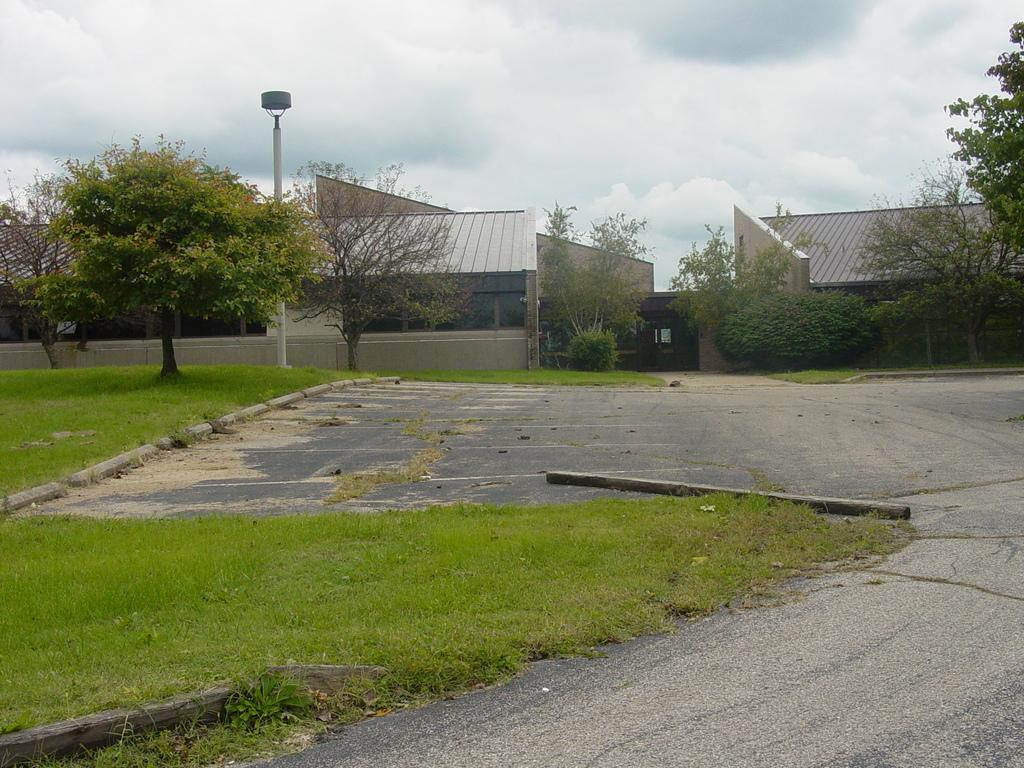Where is the image taken? The image is taken on a road. What can be seen at the bottom of the image? There is a road and green grass at the bottom of the image. What is visible in the background of the image? Houses, trees, and clouds are visible in the background of the image. What type of cabbage is growing on the wrist of the person in the image? There is no person or cabbage present in the image. How does the earth appear in the image? The image does not show the earth as a planet or any specific geographical features; it is a road scene with houses, trees, and clouds in the background. 